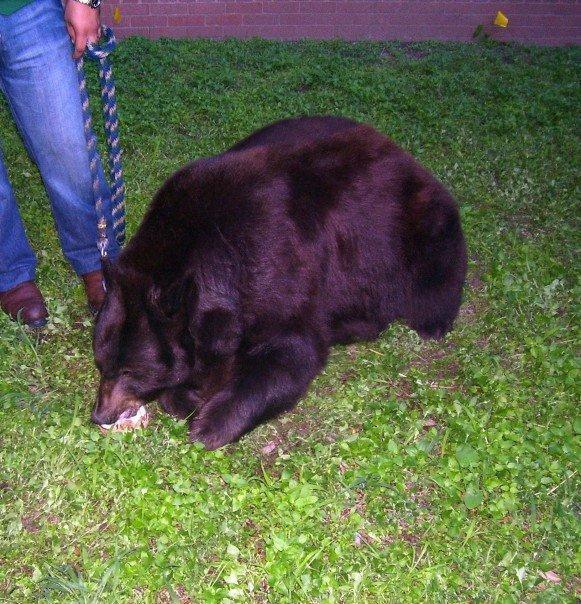How many flowers can be seen?
Give a very brief answer. 1. 